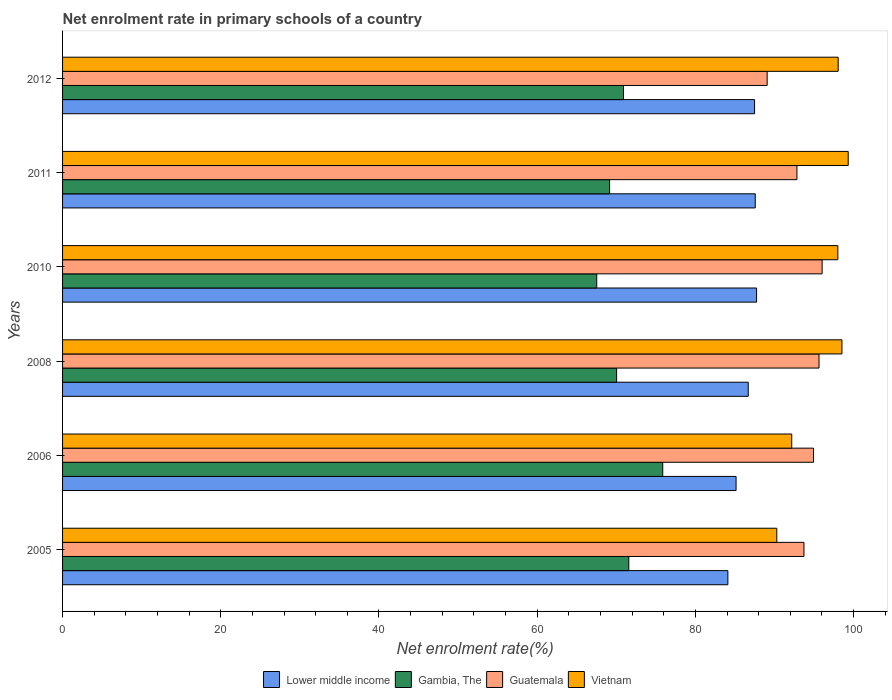How many groups of bars are there?
Your answer should be compact. 6. Are the number of bars per tick equal to the number of legend labels?
Offer a terse response. Yes. How many bars are there on the 1st tick from the top?
Your response must be concise. 4. How many bars are there on the 1st tick from the bottom?
Offer a terse response. 4. What is the label of the 3rd group of bars from the top?
Offer a very short reply. 2010. In how many cases, is the number of bars for a given year not equal to the number of legend labels?
Keep it short and to the point. 0. What is the net enrolment rate in primary schools in Vietnam in 2008?
Provide a short and direct response. 98.53. Across all years, what is the maximum net enrolment rate in primary schools in Guatemala?
Your response must be concise. 96.03. Across all years, what is the minimum net enrolment rate in primary schools in Lower middle income?
Provide a succinct answer. 84.11. In which year was the net enrolment rate in primary schools in Vietnam minimum?
Give a very brief answer. 2005. What is the total net enrolment rate in primary schools in Guatemala in the graph?
Your response must be concise. 562.25. What is the difference between the net enrolment rate in primary schools in Guatemala in 2005 and that in 2006?
Your answer should be very brief. -1.2. What is the difference between the net enrolment rate in primary schools in Vietnam in 2005 and the net enrolment rate in primary schools in Guatemala in 2011?
Offer a terse response. -2.54. What is the average net enrolment rate in primary schools in Guatemala per year?
Offer a terse response. 93.71. In the year 2010, what is the difference between the net enrolment rate in primary schools in Guatemala and net enrolment rate in primary schools in Gambia, The?
Provide a succinct answer. 28.49. What is the ratio of the net enrolment rate in primary schools in Vietnam in 2008 to that in 2011?
Provide a succinct answer. 0.99. Is the net enrolment rate in primary schools in Vietnam in 2008 less than that in 2012?
Your answer should be very brief. No. Is the difference between the net enrolment rate in primary schools in Guatemala in 2008 and 2012 greater than the difference between the net enrolment rate in primary schools in Gambia, The in 2008 and 2012?
Make the answer very short. Yes. What is the difference between the highest and the second highest net enrolment rate in primary schools in Vietnam?
Your response must be concise. 0.79. What is the difference between the highest and the lowest net enrolment rate in primary schools in Guatemala?
Your response must be concise. 6.95. Is the sum of the net enrolment rate in primary schools in Lower middle income in 2005 and 2010 greater than the maximum net enrolment rate in primary schools in Guatemala across all years?
Keep it short and to the point. Yes. Is it the case that in every year, the sum of the net enrolment rate in primary schools in Gambia, The and net enrolment rate in primary schools in Guatemala is greater than the sum of net enrolment rate in primary schools in Vietnam and net enrolment rate in primary schools in Lower middle income?
Provide a short and direct response. Yes. What does the 3rd bar from the top in 2005 represents?
Offer a terse response. Gambia, The. What does the 2nd bar from the bottom in 2006 represents?
Provide a succinct answer. Gambia, The. Is it the case that in every year, the sum of the net enrolment rate in primary schools in Gambia, The and net enrolment rate in primary schools in Vietnam is greater than the net enrolment rate in primary schools in Guatemala?
Give a very brief answer. Yes. How many bars are there?
Your response must be concise. 24. Are all the bars in the graph horizontal?
Your answer should be very brief. Yes. Are the values on the major ticks of X-axis written in scientific E-notation?
Offer a very short reply. No. What is the title of the graph?
Keep it short and to the point. Net enrolment rate in primary schools of a country. Does "Nepal" appear as one of the legend labels in the graph?
Give a very brief answer. No. What is the label or title of the X-axis?
Provide a succinct answer. Net enrolment rate(%). What is the label or title of the Y-axis?
Your answer should be very brief. Years. What is the Net enrolment rate(%) of Lower middle income in 2005?
Keep it short and to the point. 84.11. What is the Net enrolment rate(%) in Gambia, The in 2005?
Give a very brief answer. 71.59. What is the Net enrolment rate(%) of Guatemala in 2005?
Ensure brevity in your answer.  93.73. What is the Net enrolment rate(%) of Vietnam in 2005?
Provide a succinct answer. 90.3. What is the Net enrolment rate(%) in Lower middle income in 2006?
Make the answer very short. 85.15. What is the Net enrolment rate(%) in Gambia, The in 2006?
Your answer should be compact. 75.88. What is the Net enrolment rate(%) of Guatemala in 2006?
Your answer should be compact. 94.94. What is the Net enrolment rate(%) of Vietnam in 2006?
Provide a succinct answer. 92.18. What is the Net enrolment rate(%) of Lower middle income in 2008?
Offer a terse response. 86.69. What is the Net enrolment rate(%) in Gambia, The in 2008?
Offer a very short reply. 70.05. What is the Net enrolment rate(%) in Guatemala in 2008?
Make the answer very short. 95.63. What is the Net enrolment rate(%) of Vietnam in 2008?
Offer a terse response. 98.53. What is the Net enrolment rate(%) in Lower middle income in 2010?
Offer a very short reply. 87.74. What is the Net enrolment rate(%) in Gambia, The in 2010?
Ensure brevity in your answer.  67.53. What is the Net enrolment rate(%) in Guatemala in 2010?
Give a very brief answer. 96.03. What is the Net enrolment rate(%) of Vietnam in 2010?
Offer a terse response. 98.01. What is the Net enrolment rate(%) in Lower middle income in 2011?
Offer a terse response. 87.57. What is the Net enrolment rate(%) in Gambia, The in 2011?
Offer a very short reply. 69.16. What is the Net enrolment rate(%) of Guatemala in 2011?
Keep it short and to the point. 92.84. What is the Net enrolment rate(%) in Vietnam in 2011?
Your answer should be very brief. 99.32. What is the Net enrolment rate(%) in Lower middle income in 2012?
Offer a terse response. 87.49. What is the Net enrolment rate(%) of Gambia, The in 2012?
Offer a very short reply. 70.91. What is the Net enrolment rate(%) of Guatemala in 2012?
Your response must be concise. 89.08. What is the Net enrolment rate(%) of Vietnam in 2012?
Your answer should be very brief. 98.06. Across all years, what is the maximum Net enrolment rate(%) in Lower middle income?
Your response must be concise. 87.74. Across all years, what is the maximum Net enrolment rate(%) of Gambia, The?
Offer a terse response. 75.88. Across all years, what is the maximum Net enrolment rate(%) in Guatemala?
Ensure brevity in your answer.  96.03. Across all years, what is the maximum Net enrolment rate(%) in Vietnam?
Keep it short and to the point. 99.32. Across all years, what is the minimum Net enrolment rate(%) of Lower middle income?
Your response must be concise. 84.11. Across all years, what is the minimum Net enrolment rate(%) in Gambia, The?
Provide a succinct answer. 67.53. Across all years, what is the minimum Net enrolment rate(%) in Guatemala?
Provide a succinct answer. 89.08. Across all years, what is the minimum Net enrolment rate(%) in Vietnam?
Make the answer very short. 90.3. What is the total Net enrolment rate(%) in Lower middle income in the graph?
Offer a terse response. 518.75. What is the total Net enrolment rate(%) of Gambia, The in the graph?
Provide a succinct answer. 425.11. What is the total Net enrolment rate(%) of Guatemala in the graph?
Offer a terse response. 562.25. What is the total Net enrolment rate(%) in Vietnam in the graph?
Your response must be concise. 576.41. What is the difference between the Net enrolment rate(%) of Lower middle income in 2005 and that in 2006?
Offer a very short reply. -1.04. What is the difference between the Net enrolment rate(%) in Gambia, The in 2005 and that in 2006?
Give a very brief answer. -4.29. What is the difference between the Net enrolment rate(%) in Guatemala in 2005 and that in 2006?
Make the answer very short. -1.2. What is the difference between the Net enrolment rate(%) in Vietnam in 2005 and that in 2006?
Ensure brevity in your answer.  -1.89. What is the difference between the Net enrolment rate(%) of Lower middle income in 2005 and that in 2008?
Your response must be concise. -2.58. What is the difference between the Net enrolment rate(%) in Gambia, The in 2005 and that in 2008?
Give a very brief answer. 1.54. What is the difference between the Net enrolment rate(%) of Guatemala in 2005 and that in 2008?
Provide a short and direct response. -1.9. What is the difference between the Net enrolment rate(%) in Vietnam in 2005 and that in 2008?
Your response must be concise. -8.23. What is the difference between the Net enrolment rate(%) of Lower middle income in 2005 and that in 2010?
Offer a terse response. -3.63. What is the difference between the Net enrolment rate(%) in Gambia, The in 2005 and that in 2010?
Provide a succinct answer. 4.05. What is the difference between the Net enrolment rate(%) in Guatemala in 2005 and that in 2010?
Offer a very short reply. -2.29. What is the difference between the Net enrolment rate(%) of Vietnam in 2005 and that in 2010?
Your response must be concise. -7.72. What is the difference between the Net enrolment rate(%) of Lower middle income in 2005 and that in 2011?
Give a very brief answer. -3.46. What is the difference between the Net enrolment rate(%) in Gambia, The in 2005 and that in 2011?
Provide a succinct answer. 2.43. What is the difference between the Net enrolment rate(%) of Guatemala in 2005 and that in 2011?
Ensure brevity in your answer.  0.89. What is the difference between the Net enrolment rate(%) of Vietnam in 2005 and that in 2011?
Your answer should be very brief. -9.03. What is the difference between the Net enrolment rate(%) in Lower middle income in 2005 and that in 2012?
Keep it short and to the point. -3.38. What is the difference between the Net enrolment rate(%) in Gambia, The in 2005 and that in 2012?
Offer a terse response. 0.67. What is the difference between the Net enrolment rate(%) of Guatemala in 2005 and that in 2012?
Your answer should be very brief. 4.65. What is the difference between the Net enrolment rate(%) of Vietnam in 2005 and that in 2012?
Make the answer very short. -7.76. What is the difference between the Net enrolment rate(%) of Lower middle income in 2006 and that in 2008?
Provide a succinct answer. -1.54. What is the difference between the Net enrolment rate(%) of Gambia, The in 2006 and that in 2008?
Provide a succinct answer. 5.83. What is the difference between the Net enrolment rate(%) of Guatemala in 2006 and that in 2008?
Your response must be concise. -0.7. What is the difference between the Net enrolment rate(%) in Vietnam in 2006 and that in 2008?
Make the answer very short. -6.35. What is the difference between the Net enrolment rate(%) in Lower middle income in 2006 and that in 2010?
Provide a succinct answer. -2.59. What is the difference between the Net enrolment rate(%) in Gambia, The in 2006 and that in 2010?
Give a very brief answer. 8.35. What is the difference between the Net enrolment rate(%) in Guatemala in 2006 and that in 2010?
Give a very brief answer. -1.09. What is the difference between the Net enrolment rate(%) in Vietnam in 2006 and that in 2010?
Offer a very short reply. -5.83. What is the difference between the Net enrolment rate(%) of Lower middle income in 2006 and that in 2011?
Your answer should be very brief. -2.43. What is the difference between the Net enrolment rate(%) of Gambia, The in 2006 and that in 2011?
Give a very brief answer. 6.72. What is the difference between the Net enrolment rate(%) of Guatemala in 2006 and that in 2011?
Keep it short and to the point. 2.1. What is the difference between the Net enrolment rate(%) of Vietnam in 2006 and that in 2011?
Offer a very short reply. -7.14. What is the difference between the Net enrolment rate(%) of Lower middle income in 2006 and that in 2012?
Offer a terse response. -2.34. What is the difference between the Net enrolment rate(%) of Gambia, The in 2006 and that in 2012?
Provide a succinct answer. 4.97. What is the difference between the Net enrolment rate(%) in Guatemala in 2006 and that in 2012?
Ensure brevity in your answer.  5.86. What is the difference between the Net enrolment rate(%) of Vietnam in 2006 and that in 2012?
Keep it short and to the point. -5.87. What is the difference between the Net enrolment rate(%) of Lower middle income in 2008 and that in 2010?
Give a very brief answer. -1.06. What is the difference between the Net enrolment rate(%) in Gambia, The in 2008 and that in 2010?
Offer a very short reply. 2.51. What is the difference between the Net enrolment rate(%) in Guatemala in 2008 and that in 2010?
Ensure brevity in your answer.  -0.39. What is the difference between the Net enrolment rate(%) of Vietnam in 2008 and that in 2010?
Provide a short and direct response. 0.52. What is the difference between the Net enrolment rate(%) in Lower middle income in 2008 and that in 2011?
Your response must be concise. -0.89. What is the difference between the Net enrolment rate(%) in Gambia, The in 2008 and that in 2011?
Offer a very short reply. 0.89. What is the difference between the Net enrolment rate(%) of Guatemala in 2008 and that in 2011?
Offer a very short reply. 2.79. What is the difference between the Net enrolment rate(%) in Vietnam in 2008 and that in 2011?
Offer a very short reply. -0.79. What is the difference between the Net enrolment rate(%) of Lower middle income in 2008 and that in 2012?
Provide a short and direct response. -0.8. What is the difference between the Net enrolment rate(%) of Gambia, The in 2008 and that in 2012?
Your answer should be very brief. -0.87. What is the difference between the Net enrolment rate(%) of Guatemala in 2008 and that in 2012?
Give a very brief answer. 6.56. What is the difference between the Net enrolment rate(%) of Vietnam in 2008 and that in 2012?
Your response must be concise. 0.47. What is the difference between the Net enrolment rate(%) in Lower middle income in 2010 and that in 2011?
Keep it short and to the point. 0.17. What is the difference between the Net enrolment rate(%) of Gambia, The in 2010 and that in 2011?
Offer a very short reply. -1.63. What is the difference between the Net enrolment rate(%) in Guatemala in 2010 and that in 2011?
Offer a terse response. 3.19. What is the difference between the Net enrolment rate(%) in Vietnam in 2010 and that in 2011?
Provide a short and direct response. -1.31. What is the difference between the Net enrolment rate(%) of Lower middle income in 2010 and that in 2012?
Ensure brevity in your answer.  0.25. What is the difference between the Net enrolment rate(%) of Gambia, The in 2010 and that in 2012?
Provide a succinct answer. -3.38. What is the difference between the Net enrolment rate(%) of Guatemala in 2010 and that in 2012?
Ensure brevity in your answer.  6.95. What is the difference between the Net enrolment rate(%) of Vietnam in 2010 and that in 2012?
Ensure brevity in your answer.  -0.04. What is the difference between the Net enrolment rate(%) of Lower middle income in 2011 and that in 2012?
Give a very brief answer. 0.09. What is the difference between the Net enrolment rate(%) of Gambia, The in 2011 and that in 2012?
Keep it short and to the point. -1.75. What is the difference between the Net enrolment rate(%) of Guatemala in 2011 and that in 2012?
Give a very brief answer. 3.76. What is the difference between the Net enrolment rate(%) of Vietnam in 2011 and that in 2012?
Your answer should be compact. 1.27. What is the difference between the Net enrolment rate(%) in Lower middle income in 2005 and the Net enrolment rate(%) in Gambia, The in 2006?
Ensure brevity in your answer.  8.23. What is the difference between the Net enrolment rate(%) of Lower middle income in 2005 and the Net enrolment rate(%) of Guatemala in 2006?
Your answer should be compact. -10.83. What is the difference between the Net enrolment rate(%) in Lower middle income in 2005 and the Net enrolment rate(%) in Vietnam in 2006?
Make the answer very short. -8.07. What is the difference between the Net enrolment rate(%) of Gambia, The in 2005 and the Net enrolment rate(%) of Guatemala in 2006?
Make the answer very short. -23.35. What is the difference between the Net enrolment rate(%) of Gambia, The in 2005 and the Net enrolment rate(%) of Vietnam in 2006?
Provide a short and direct response. -20.6. What is the difference between the Net enrolment rate(%) of Guatemala in 2005 and the Net enrolment rate(%) of Vietnam in 2006?
Provide a succinct answer. 1.55. What is the difference between the Net enrolment rate(%) in Lower middle income in 2005 and the Net enrolment rate(%) in Gambia, The in 2008?
Your response must be concise. 14.06. What is the difference between the Net enrolment rate(%) in Lower middle income in 2005 and the Net enrolment rate(%) in Guatemala in 2008?
Your response must be concise. -11.52. What is the difference between the Net enrolment rate(%) of Lower middle income in 2005 and the Net enrolment rate(%) of Vietnam in 2008?
Keep it short and to the point. -14.42. What is the difference between the Net enrolment rate(%) in Gambia, The in 2005 and the Net enrolment rate(%) in Guatemala in 2008?
Provide a succinct answer. -24.05. What is the difference between the Net enrolment rate(%) of Gambia, The in 2005 and the Net enrolment rate(%) of Vietnam in 2008?
Provide a short and direct response. -26.95. What is the difference between the Net enrolment rate(%) in Guatemala in 2005 and the Net enrolment rate(%) in Vietnam in 2008?
Offer a terse response. -4.8. What is the difference between the Net enrolment rate(%) of Lower middle income in 2005 and the Net enrolment rate(%) of Gambia, The in 2010?
Offer a terse response. 16.58. What is the difference between the Net enrolment rate(%) of Lower middle income in 2005 and the Net enrolment rate(%) of Guatemala in 2010?
Your answer should be very brief. -11.92. What is the difference between the Net enrolment rate(%) of Lower middle income in 2005 and the Net enrolment rate(%) of Vietnam in 2010?
Your answer should be very brief. -13.9. What is the difference between the Net enrolment rate(%) of Gambia, The in 2005 and the Net enrolment rate(%) of Guatemala in 2010?
Ensure brevity in your answer.  -24.44. What is the difference between the Net enrolment rate(%) in Gambia, The in 2005 and the Net enrolment rate(%) in Vietnam in 2010?
Make the answer very short. -26.43. What is the difference between the Net enrolment rate(%) of Guatemala in 2005 and the Net enrolment rate(%) of Vietnam in 2010?
Your answer should be very brief. -4.28. What is the difference between the Net enrolment rate(%) of Lower middle income in 2005 and the Net enrolment rate(%) of Gambia, The in 2011?
Your answer should be compact. 14.95. What is the difference between the Net enrolment rate(%) in Lower middle income in 2005 and the Net enrolment rate(%) in Guatemala in 2011?
Your answer should be very brief. -8.73. What is the difference between the Net enrolment rate(%) of Lower middle income in 2005 and the Net enrolment rate(%) of Vietnam in 2011?
Provide a short and direct response. -15.21. What is the difference between the Net enrolment rate(%) of Gambia, The in 2005 and the Net enrolment rate(%) of Guatemala in 2011?
Keep it short and to the point. -21.26. What is the difference between the Net enrolment rate(%) in Gambia, The in 2005 and the Net enrolment rate(%) in Vietnam in 2011?
Your answer should be compact. -27.74. What is the difference between the Net enrolment rate(%) of Guatemala in 2005 and the Net enrolment rate(%) of Vietnam in 2011?
Your answer should be compact. -5.59. What is the difference between the Net enrolment rate(%) in Lower middle income in 2005 and the Net enrolment rate(%) in Gambia, The in 2012?
Offer a very short reply. 13.2. What is the difference between the Net enrolment rate(%) in Lower middle income in 2005 and the Net enrolment rate(%) in Guatemala in 2012?
Offer a terse response. -4.97. What is the difference between the Net enrolment rate(%) of Lower middle income in 2005 and the Net enrolment rate(%) of Vietnam in 2012?
Offer a terse response. -13.95. What is the difference between the Net enrolment rate(%) of Gambia, The in 2005 and the Net enrolment rate(%) of Guatemala in 2012?
Ensure brevity in your answer.  -17.49. What is the difference between the Net enrolment rate(%) of Gambia, The in 2005 and the Net enrolment rate(%) of Vietnam in 2012?
Your answer should be very brief. -26.47. What is the difference between the Net enrolment rate(%) in Guatemala in 2005 and the Net enrolment rate(%) in Vietnam in 2012?
Your answer should be very brief. -4.32. What is the difference between the Net enrolment rate(%) of Lower middle income in 2006 and the Net enrolment rate(%) of Gambia, The in 2008?
Your answer should be very brief. 15.1. What is the difference between the Net enrolment rate(%) of Lower middle income in 2006 and the Net enrolment rate(%) of Guatemala in 2008?
Your response must be concise. -10.49. What is the difference between the Net enrolment rate(%) in Lower middle income in 2006 and the Net enrolment rate(%) in Vietnam in 2008?
Ensure brevity in your answer.  -13.38. What is the difference between the Net enrolment rate(%) of Gambia, The in 2006 and the Net enrolment rate(%) of Guatemala in 2008?
Keep it short and to the point. -19.76. What is the difference between the Net enrolment rate(%) in Gambia, The in 2006 and the Net enrolment rate(%) in Vietnam in 2008?
Offer a very short reply. -22.65. What is the difference between the Net enrolment rate(%) in Guatemala in 2006 and the Net enrolment rate(%) in Vietnam in 2008?
Your answer should be very brief. -3.59. What is the difference between the Net enrolment rate(%) in Lower middle income in 2006 and the Net enrolment rate(%) in Gambia, The in 2010?
Offer a terse response. 17.62. What is the difference between the Net enrolment rate(%) in Lower middle income in 2006 and the Net enrolment rate(%) in Guatemala in 2010?
Provide a succinct answer. -10.88. What is the difference between the Net enrolment rate(%) in Lower middle income in 2006 and the Net enrolment rate(%) in Vietnam in 2010?
Your answer should be compact. -12.87. What is the difference between the Net enrolment rate(%) in Gambia, The in 2006 and the Net enrolment rate(%) in Guatemala in 2010?
Ensure brevity in your answer.  -20.15. What is the difference between the Net enrolment rate(%) in Gambia, The in 2006 and the Net enrolment rate(%) in Vietnam in 2010?
Offer a terse response. -22.14. What is the difference between the Net enrolment rate(%) of Guatemala in 2006 and the Net enrolment rate(%) of Vietnam in 2010?
Provide a succinct answer. -3.08. What is the difference between the Net enrolment rate(%) in Lower middle income in 2006 and the Net enrolment rate(%) in Gambia, The in 2011?
Ensure brevity in your answer.  15.99. What is the difference between the Net enrolment rate(%) of Lower middle income in 2006 and the Net enrolment rate(%) of Guatemala in 2011?
Ensure brevity in your answer.  -7.69. What is the difference between the Net enrolment rate(%) of Lower middle income in 2006 and the Net enrolment rate(%) of Vietnam in 2011?
Provide a short and direct response. -14.18. What is the difference between the Net enrolment rate(%) of Gambia, The in 2006 and the Net enrolment rate(%) of Guatemala in 2011?
Ensure brevity in your answer.  -16.96. What is the difference between the Net enrolment rate(%) in Gambia, The in 2006 and the Net enrolment rate(%) in Vietnam in 2011?
Give a very brief answer. -23.45. What is the difference between the Net enrolment rate(%) in Guatemala in 2006 and the Net enrolment rate(%) in Vietnam in 2011?
Your answer should be compact. -4.39. What is the difference between the Net enrolment rate(%) of Lower middle income in 2006 and the Net enrolment rate(%) of Gambia, The in 2012?
Keep it short and to the point. 14.24. What is the difference between the Net enrolment rate(%) of Lower middle income in 2006 and the Net enrolment rate(%) of Guatemala in 2012?
Keep it short and to the point. -3.93. What is the difference between the Net enrolment rate(%) of Lower middle income in 2006 and the Net enrolment rate(%) of Vietnam in 2012?
Keep it short and to the point. -12.91. What is the difference between the Net enrolment rate(%) of Gambia, The in 2006 and the Net enrolment rate(%) of Guatemala in 2012?
Offer a very short reply. -13.2. What is the difference between the Net enrolment rate(%) in Gambia, The in 2006 and the Net enrolment rate(%) in Vietnam in 2012?
Your answer should be compact. -22.18. What is the difference between the Net enrolment rate(%) in Guatemala in 2006 and the Net enrolment rate(%) in Vietnam in 2012?
Make the answer very short. -3.12. What is the difference between the Net enrolment rate(%) in Lower middle income in 2008 and the Net enrolment rate(%) in Gambia, The in 2010?
Give a very brief answer. 19.15. What is the difference between the Net enrolment rate(%) in Lower middle income in 2008 and the Net enrolment rate(%) in Guatemala in 2010?
Your answer should be very brief. -9.34. What is the difference between the Net enrolment rate(%) in Lower middle income in 2008 and the Net enrolment rate(%) in Vietnam in 2010?
Offer a very short reply. -11.33. What is the difference between the Net enrolment rate(%) in Gambia, The in 2008 and the Net enrolment rate(%) in Guatemala in 2010?
Ensure brevity in your answer.  -25.98. What is the difference between the Net enrolment rate(%) in Gambia, The in 2008 and the Net enrolment rate(%) in Vietnam in 2010?
Provide a short and direct response. -27.97. What is the difference between the Net enrolment rate(%) of Guatemala in 2008 and the Net enrolment rate(%) of Vietnam in 2010?
Make the answer very short. -2.38. What is the difference between the Net enrolment rate(%) of Lower middle income in 2008 and the Net enrolment rate(%) of Gambia, The in 2011?
Ensure brevity in your answer.  17.53. What is the difference between the Net enrolment rate(%) of Lower middle income in 2008 and the Net enrolment rate(%) of Guatemala in 2011?
Give a very brief answer. -6.15. What is the difference between the Net enrolment rate(%) of Lower middle income in 2008 and the Net enrolment rate(%) of Vietnam in 2011?
Offer a terse response. -12.64. What is the difference between the Net enrolment rate(%) in Gambia, The in 2008 and the Net enrolment rate(%) in Guatemala in 2011?
Offer a terse response. -22.79. What is the difference between the Net enrolment rate(%) of Gambia, The in 2008 and the Net enrolment rate(%) of Vietnam in 2011?
Give a very brief answer. -29.28. What is the difference between the Net enrolment rate(%) in Guatemala in 2008 and the Net enrolment rate(%) in Vietnam in 2011?
Make the answer very short. -3.69. What is the difference between the Net enrolment rate(%) in Lower middle income in 2008 and the Net enrolment rate(%) in Gambia, The in 2012?
Your answer should be very brief. 15.77. What is the difference between the Net enrolment rate(%) of Lower middle income in 2008 and the Net enrolment rate(%) of Guatemala in 2012?
Your answer should be very brief. -2.39. What is the difference between the Net enrolment rate(%) of Lower middle income in 2008 and the Net enrolment rate(%) of Vietnam in 2012?
Offer a terse response. -11.37. What is the difference between the Net enrolment rate(%) of Gambia, The in 2008 and the Net enrolment rate(%) of Guatemala in 2012?
Provide a succinct answer. -19.03. What is the difference between the Net enrolment rate(%) of Gambia, The in 2008 and the Net enrolment rate(%) of Vietnam in 2012?
Your response must be concise. -28.01. What is the difference between the Net enrolment rate(%) of Guatemala in 2008 and the Net enrolment rate(%) of Vietnam in 2012?
Your answer should be very brief. -2.42. What is the difference between the Net enrolment rate(%) of Lower middle income in 2010 and the Net enrolment rate(%) of Gambia, The in 2011?
Keep it short and to the point. 18.58. What is the difference between the Net enrolment rate(%) of Lower middle income in 2010 and the Net enrolment rate(%) of Guatemala in 2011?
Keep it short and to the point. -5.1. What is the difference between the Net enrolment rate(%) of Lower middle income in 2010 and the Net enrolment rate(%) of Vietnam in 2011?
Ensure brevity in your answer.  -11.58. What is the difference between the Net enrolment rate(%) in Gambia, The in 2010 and the Net enrolment rate(%) in Guatemala in 2011?
Offer a very short reply. -25.31. What is the difference between the Net enrolment rate(%) of Gambia, The in 2010 and the Net enrolment rate(%) of Vietnam in 2011?
Provide a succinct answer. -31.79. What is the difference between the Net enrolment rate(%) in Guatemala in 2010 and the Net enrolment rate(%) in Vietnam in 2011?
Offer a very short reply. -3.3. What is the difference between the Net enrolment rate(%) of Lower middle income in 2010 and the Net enrolment rate(%) of Gambia, The in 2012?
Offer a terse response. 16.83. What is the difference between the Net enrolment rate(%) in Lower middle income in 2010 and the Net enrolment rate(%) in Guatemala in 2012?
Your response must be concise. -1.33. What is the difference between the Net enrolment rate(%) in Lower middle income in 2010 and the Net enrolment rate(%) in Vietnam in 2012?
Provide a succinct answer. -10.31. What is the difference between the Net enrolment rate(%) in Gambia, The in 2010 and the Net enrolment rate(%) in Guatemala in 2012?
Your response must be concise. -21.54. What is the difference between the Net enrolment rate(%) in Gambia, The in 2010 and the Net enrolment rate(%) in Vietnam in 2012?
Your answer should be compact. -30.52. What is the difference between the Net enrolment rate(%) of Guatemala in 2010 and the Net enrolment rate(%) of Vietnam in 2012?
Give a very brief answer. -2.03. What is the difference between the Net enrolment rate(%) in Lower middle income in 2011 and the Net enrolment rate(%) in Gambia, The in 2012?
Make the answer very short. 16.66. What is the difference between the Net enrolment rate(%) in Lower middle income in 2011 and the Net enrolment rate(%) in Guatemala in 2012?
Ensure brevity in your answer.  -1.5. What is the difference between the Net enrolment rate(%) in Lower middle income in 2011 and the Net enrolment rate(%) in Vietnam in 2012?
Your answer should be very brief. -10.48. What is the difference between the Net enrolment rate(%) of Gambia, The in 2011 and the Net enrolment rate(%) of Guatemala in 2012?
Ensure brevity in your answer.  -19.92. What is the difference between the Net enrolment rate(%) in Gambia, The in 2011 and the Net enrolment rate(%) in Vietnam in 2012?
Provide a short and direct response. -28.9. What is the difference between the Net enrolment rate(%) of Guatemala in 2011 and the Net enrolment rate(%) of Vietnam in 2012?
Give a very brief answer. -5.22. What is the average Net enrolment rate(%) in Lower middle income per year?
Provide a succinct answer. 86.46. What is the average Net enrolment rate(%) in Gambia, The per year?
Ensure brevity in your answer.  70.85. What is the average Net enrolment rate(%) of Guatemala per year?
Make the answer very short. 93.71. What is the average Net enrolment rate(%) of Vietnam per year?
Make the answer very short. 96.07. In the year 2005, what is the difference between the Net enrolment rate(%) of Lower middle income and Net enrolment rate(%) of Gambia, The?
Offer a very short reply. 12.53. In the year 2005, what is the difference between the Net enrolment rate(%) in Lower middle income and Net enrolment rate(%) in Guatemala?
Keep it short and to the point. -9.62. In the year 2005, what is the difference between the Net enrolment rate(%) in Lower middle income and Net enrolment rate(%) in Vietnam?
Your answer should be compact. -6.19. In the year 2005, what is the difference between the Net enrolment rate(%) in Gambia, The and Net enrolment rate(%) in Guatemala?
Your response must be concise. -22.15. In the year 2005, what is the difference between the Net enrolment rate(%) in Gambia, The and Net enrolment rate(%) in Vietnam?
Provide a succinct answer. -18.71. In the year 2005, what is the difference between the Net enrolment rate(%) in Guatemala and Net enrolment rate(%) in Vietnam?
Your answer should be compact. 3.44. In the year 2006, what is the difference between the Net enrolment rate(%) of Lower middle income and Net enrolment rate(%) of Gambia, The?
Make the answer very short. 9.27. In the year 2006, what is the difference between the Net enrolment rate(%) in Lower middle income and Net enrolment rate(%) in Guatemala?
Provide a succinct answer. -9.79. In the year 2006, what is the difference between the Net enrolment rate(%) in Lower middle income and Net enrolment rate(%) in Vietnam?
Ensure brevity in your answer.  -7.04. In the year 2006, what is the difference between the Net enrolment rate(%) in Gambia, The and Net enrolment rate(%) in Guatemala?
Your answer should be very brief. -19.06. In the year 2006, what is the difference between the Net enrolment rate(%) of Gambia, The and Net enrolment rate(%) of Vietnam?
Give a very brief answer. -16.31. In the year 2006, what is the difference between the Net enrolment rate(%) of Guatemala and Net enrolment rate(%) of Vietnam?
Make the answer very short. 2.75. In the year 2008, what is the difference between the Net enrolment rate(%) of Lower middle income and Net enrolment rate(%) of Gambia, The?
Your response must be concise. 16.64. In the year 2008, what is the difference between the Net enrolment rate(%) of Lower middle income and Net enrolment rate(%) of Guatemala?
Make the answer very short. -8.95. In the year 2008, what is the difference between the Net enrolment rate(%) in Lower middle income and Net enrolment rate(%) in Vietnam?
Keep it short and to the point. -11.84. In the year 2008, what is the difference between the Net enrolment rate(%) of Gambia, The and Net enrolment rate(%) of Guatemala?
Your answer should be compact. -25.59. In the year 2008, what is the difference between the Net enrolment rate(%) in Gambia, The and Net enrolment rate(%) in Vietnam?
Keep it short and to the point. -28.48. In the year 2008, what is the difference between the Net enrolment rate(%) of Guatemala and Net enrolment rate(%) of Vietnam?
Your answer should be very brief. -2.9. In the year 2010, what is the difference between the Net enrolment rate(%) of Lower middle income and Net enrolment rate(%) of Gambia, The?
Offer a terse response. 20.21. In the year 2010, what is the difference between the Net enrolment rate(%) in Lower middle income and Net enrolment rate(%) in Guatemala?
Offer a very short reply. -8.28. In the year 2010, what is the difference between the Net enrolment rate(%) of Lower middle income and Net enrolment rate(%) of Vietnam?
Your response must be concise. -10.27. In the year 2010, what is the difference between the Net enrolment rate(%) of Gambia, The and Net enrolment rate(%) of Guatemala?
Your response must be concise. -28.49. In the year 2010, what is the difference between the Net enrolment rate(%) of Gambia, The and Net enrolment rate(%) of Vietnam?
Your answer should be very brief. -30.48. In the year 2010, what is the difference between the Net enrolment rate(%) in Guatemala and Net enrolment rate(%) in Vietnam?
Provide a short and direct response. -1.99. In the year 2011, what is the difference between the Net enrolment rate(%) in Lower middle income and Net enrolment rate(%) in Gambia, The?
Offer a very short reply. 18.42. In the year 2011, what is the difference between the Net enrolment rate(%) in Lower middle income and Net enrolment rate(%) in Guatemala?
Give a very brief answer. -5.27. In the year 2011, what is the difference between the Net enrolment rate(%) in Lower middle income and Net enrolment rate(%) in Vietnam?
Offer a very short reply. -11.75. In the year 2011, what is the difference between the Net enrolment rate(%) of Gambia, The and Net enrolment rate(%) of Guatemala?
Give a very brief answer. -23.68. In the year 2011, what is the difference between the Net enrolment rate(%) in Gambia, The and Net enrolment rate(%) in Vietnam?
Make the answer very short. -30.17. In the year 2011, what is the difference between the Net enrolment rate(%) of Guatemala and Net enrolment rate(%) of Vietnam?
Provide a short and direct response. -6.48. In the year 2012, what is the difference between the Net enrolment rate(%) in Lower middle income and Net enrolment rate(%) in Gambia, The?
Give a very brief answer. 16.57. In the year 2012, what is the difference between the Net enrolment rate(%) of Lower middle income and Net enrolment rate(%) of Guatemala?
Keep it short and to the point. -1.59. In the year 2012, what is the difference between the Net enrolment rate(%) in Lower middle income and Net enrolment rate(%) in Vietnam?
Provide a short and direct response. -10.57. In the year 2012, what is the difference between the Net enrolment rate(%) in Gambia, The and Net enrolment rate(%) in Guatemala?
Provide a short and direct response. -18.16. In the year 2012, what is the difference between the Net enrolment rate(%) in Gambia, The and Net enrolment rate(%) in Vietnam?
Your response must be concise. -27.14. In the year 2012, what is the difference between the Net enrolment rate(%) of Guatemala and Net enrolment rate(%) of Vietnam?
Provide a succinct answer. -8.98. What is the ratio of the Net enrolment rate(%) of Gambia, The in 2005 to that in 2006?
Offer a very short reply. 0.94. What is the ratio of the Net enrolment rate(%) in Guatemala in 2005 to that in 2006?
Give a very brief answer. 0.99. What is the ratio of the Net enrolment rate(%) in Vietnam in 2005 to that in 2006?
Keep it short and to the point. 0.98. What is the ratio of the Net enrolment rate(%) in Lower middle income in 2005 to that in 2008?
Keep it short and to the point. 0.97. What is the ratio of the Net enrolment rate(%) in Gambia, The in 2005 to that in 2008?
Your answer should be very brief. 1.02. What is the ratio of the Net enrolment rate(%) in Guatemala in 2005 to that in 2008?
Offer a very short reply. 0.98. What is the ratio of the Net enrolment rate(%) of Vietnam in 2005 to that in 2008?
Give a very brief answer. 0.92. What is the ratio of the Net enrolment rate(%) in Lower middle income in 2005 to that in 2010?
Your answer should be compact. 0.96. What is the ratio of the Net enrolment rate(%) of Gambia, The in 2005 to that in 2010?
Your answer should be very brief. 1.06. What is the ratio of the Net enrolment rate(%) of Guatemala in 2005 to that in 2010?
Your response must be concise. 0.98. What is the ratio of the Net enrolment rate(%) of Vietnam in 2005 to that in 2010?
Your answer should be very brief. 0.92. What is the ratio of the Net enrolment rate(%) of Lower middle income in 2005 to that in 2011?
Offer a terse response. 0.96. What is the ratio of the Net enrolment rate(%) in Gambia, The in 2005 to that in 2011?
Keep it short and to the point. 1.04. What is the ratio of the Net enrolment rate(%) of Guatemala in 2005 to that in 2011?
Offer a terse response. 1.01. What is the ratio of the Net enrolment rate(%) of Vietnam in 2005 to that in 2011?
Provide a short and direct response. 0.91. What is the ratio of the Net enrolment rate(%) in Lower middle income in 2005 to that in 2012?
Keep it short and to the point. 0.96. What is the ratio of the Net enrolment rate(%) of Gambia, The in 2005 to that in 2012?
Give a very brief answer. 1.01. What is the ratio of the Net enrolment rate(%) in Guatemala in 2005 to that in 2012?
Your response must be concise. 1.05. What is the ratio of the Net enrolment rate(%) in Vietnam in 2005 to that in 2012?
Give a very brief answer. 0.92. What is the ratio of the Net enrolment rate(%) of Lower middle income in 2006 to that in 2008?
Your answer should be very brief. 0.98. What is the ratio of the Net enrolment rate(%) in Gambia, The in 2006 to that in 2008?
Your answer should be very brief. 1.08. What is the ratio of the Net enrolment rate(%) of Guatemala in 2006 to that in 2008?
Offer a very short reply. 0.99. What is the ratio of the Net enrolment rate(%) in Vietnam in 2006 to that in 2008?
Give a very brief answer. 0.94. What is the ratio of the Net enrolment rate(%) of Lower middle income in 2006 to that in 2010?
Your response must be concise. 0.97. What is the ratio of the Net enrolment rate(%) in Gambia, The in 2006 to that in 2010?
Your answer should be compact. 1.12. What is the ratio of the Net enrolment rate(%) of Guatemala in 2006 to that in 2010?
Provide a succinct answer. 0.99. What is the ratio of the Net enrolment rate(%) in Vietnam in 2006 to that in 2010?
Ensure brevity in your answer.  0.94. What is the ratio of the Net enrolment rate(%) in Lower middle income in 2006 to that in 2011?
Provide a succinct answer. 0.97. What is the ratio of the Net enrolment rate(%) in Gambia, The in 2006 to that in 2011?
Provide a short and direct response. 1.1. What is the ratio of the Net enrolment rate(%) in Guatemala in 2006 to that in 2011?
Provide a succinct answer. 1.02. What is the ratio of the Net enrolment rate(%) in Vietnam in 2006 to that in 2011?
Your response must be concise. 0.93. What is the ratio of the Net enrolment rate(%) of Lower middle income in 2006 to that in 2012?
Offer a very short reply. 0.97. What is the ratio of the Net enrolment rate(%) of Gambia, The in 2006 to that in 2012?
Provide a short and direct response. 1.07. What is the ratio of the Net enrolment rate(%) in Guatemala in 2006 to that in 2012?
Offer a very short reply. 1.07. What is the ratio of the Net enrolment rate(%) of Vietnam in 2006 to that in 2012?
Offer a very short reply. 0.94. What is the ratio of the Net enrolment rate(%) of Lower middle income in 2008 to that in 2010?
Keep it short and to the point. 0.99. What is the ratio of the Net enrolment rate(%) in Gambia, The in 2008 to that in 2010?
Keep it short and to the point. 1.04. What is the ratio of the Net enrolment rate(%) in Vietnam in 2008 to that in 2010?
Offer a terse response. 1.01. What is the ratio of the Net enrolment rate(%) in Lower middle income in 2008 to that in 2011?
Your answer should be compact. 0.99. What is the ratio of the Net enrolment rate(%) in Gambia, The in 2008 to that in 2011?
Your answer should be very brief. 1.01. What is the ratio of the Net enrolment rate(%) in Guatemala in 2008 to that in 2011?
Offer a very short reply. 1.03. What is the ratio of the Net enrolment rate(%) in Vietnam in 2008 to that in 2011?
Your answer should be compact. 0.99. What is the ratio of the Net enrolment rate(%) in Lower middle income in 2008 to that in 2012?
Give a very brief answer. 0.99. What is the ratio of the Net enrolment rate(%) in Guatemala in 2008 to that in 2012?
Provide a succinct answer. 1.07. What is the ratio of the Net enrolment rate(%) of Lower middle income in 2010 to that in 2011?
Give a very brief answer. 1. What is the ratio of the Net enrolment rate(%) in Gambia, The in 2010 to that in 2011?
Offer a very short reply. 0.98. What is the ratio of the Net enrolment rate(%) of Guatemala in 2010 to that in 2011?
Offer a terse response. 1.03. What is the ratio of the Net enrolment rate(%) of Gambia, The in 2010 to that in 2012?
Offer a terse response. 0.95. What is the ratio of the Net enrolment rate(%) of Guatemala in 2010 to that in 2012?
Offer a terse response. 1.08. What is the ratio of the Net enrolment rate(%) in Lower middle income in 2011 to that in 2012?
Your response must be concise. 1. What is the ratio of the Net enrolment rate(%) of Gambia, The in 2011 to that in 2012?
Keep it short and to the point. 0.98. What is the ratio of the Net enrolment rate(%) in Guatemala in 2011 to that in 2012?
Provide a succinct answer. 1.04. What is the ratio of the Net enrolment rate(%) of Vietnam in 2011 to that in 2012?
Give a very brief answer. 1.01. What is the difference between the highest and the second highest Net enrolment rate(%) of Lower middle income?
Make the answer very short. 0.17. What is the difference between the highest and the second highest Net enrolment rate(%) of Gambia, The?
Make the answer very short. 4.29. What is the difference between the highest and the second highest Net enrolment rate(%) in Guatemala?
Keep it short and to the point. 0.39. What is the difference between the highest and the second highest Net enrolment rate(%) in Vietnam?
Provide a succinct answer. 0.79. What is the difference between the highest and the lowest Net enrolment rate(%) in Lower middle income?
Provide a succinct answer. 3.63. What is the difference between the highest and the lowest Net enrolment rate(%) of Gambia, The?
Provide a succinct answer. 8.35. What is the difference between the highest and the lowest Net enrolment rate(%) in Guatemala?
Provide a succinct answer. 6.95. What is the difference between the highest and the lowest Net enrolment rate(%) in Vietnam?
Give a very brief answer. 9.03. 